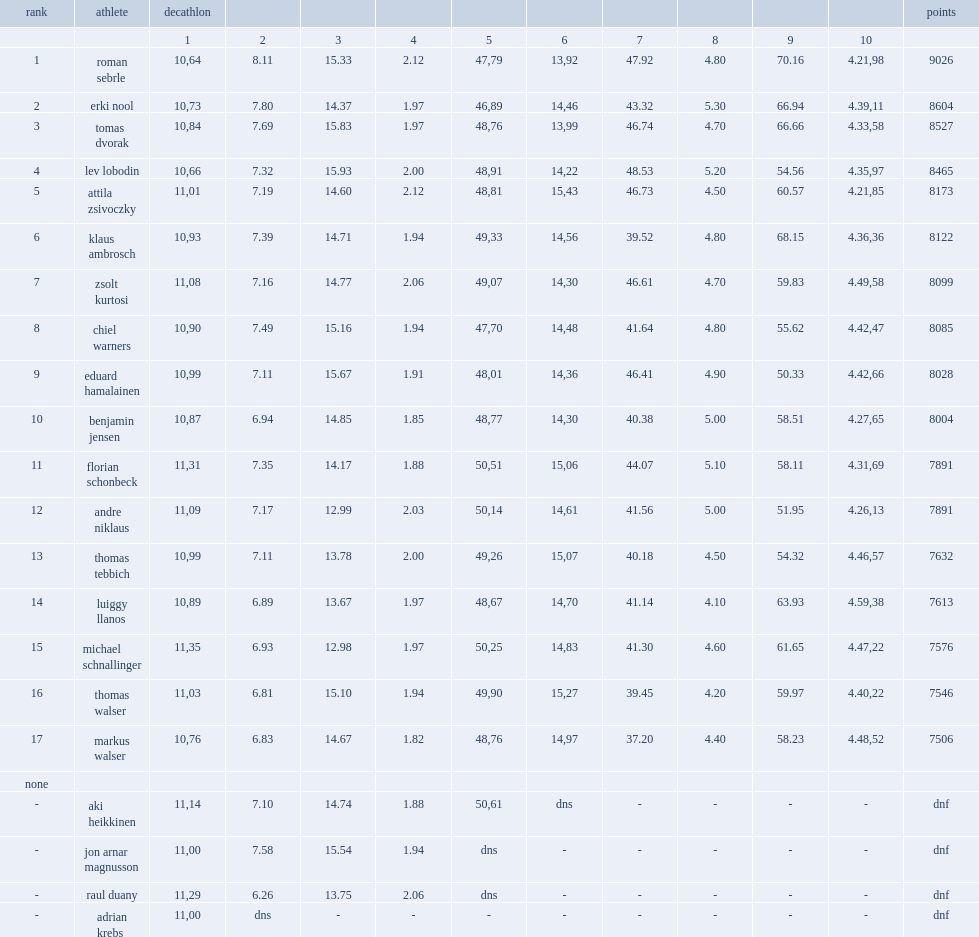How many points did roman sebrle get in the decathlon? 9026.0. 